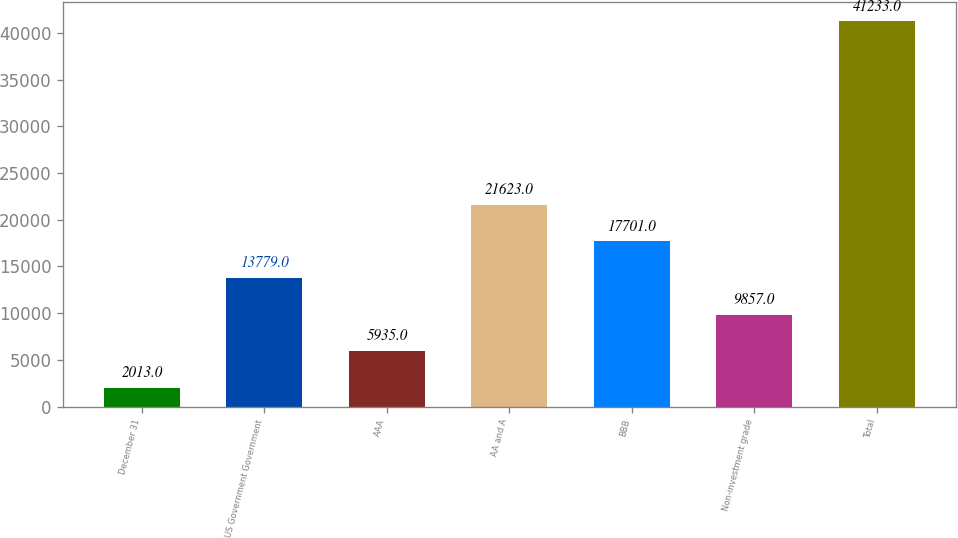<chart> <loc_0><loc_0><loc_500><loc_500><bar_chart><fcel>December 31<fcel>US Government Government<fcel>AAA<fcel>AA and A<fcel>BBB<fcel>Non-investment grade<fcel>Total<nl><fcel>2013<fcel>13779<fcel>5935<fcel>21623<fcel>17701<fcel>9857<fcel>41233<nl></chart> 